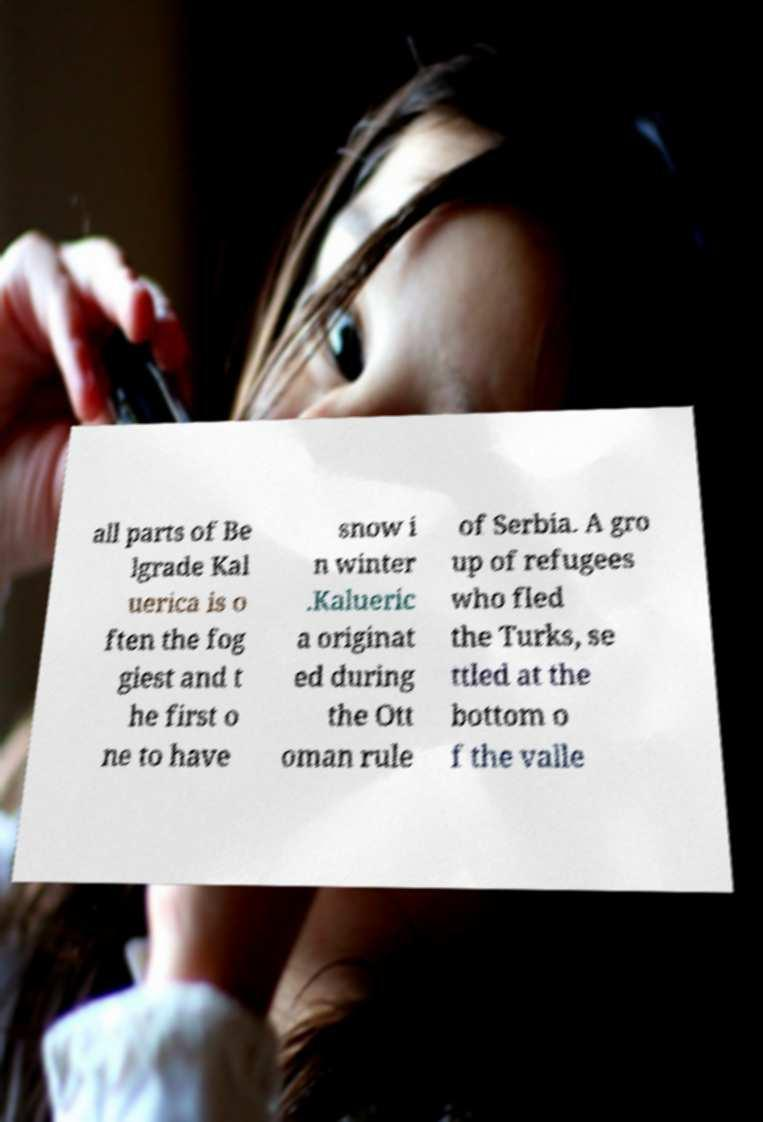For documentation purposes, I need the text within this image transcribed. Could you provide that? all parts of Be lgrade Kal uerica is o ften the fog giest and t he first o ne to have snow i n winter .Kalueric a originat ed during the Ott oman rule of Serbia. A gro up of refugees who fled the Turks, se ttled at the bottom o f the valle 